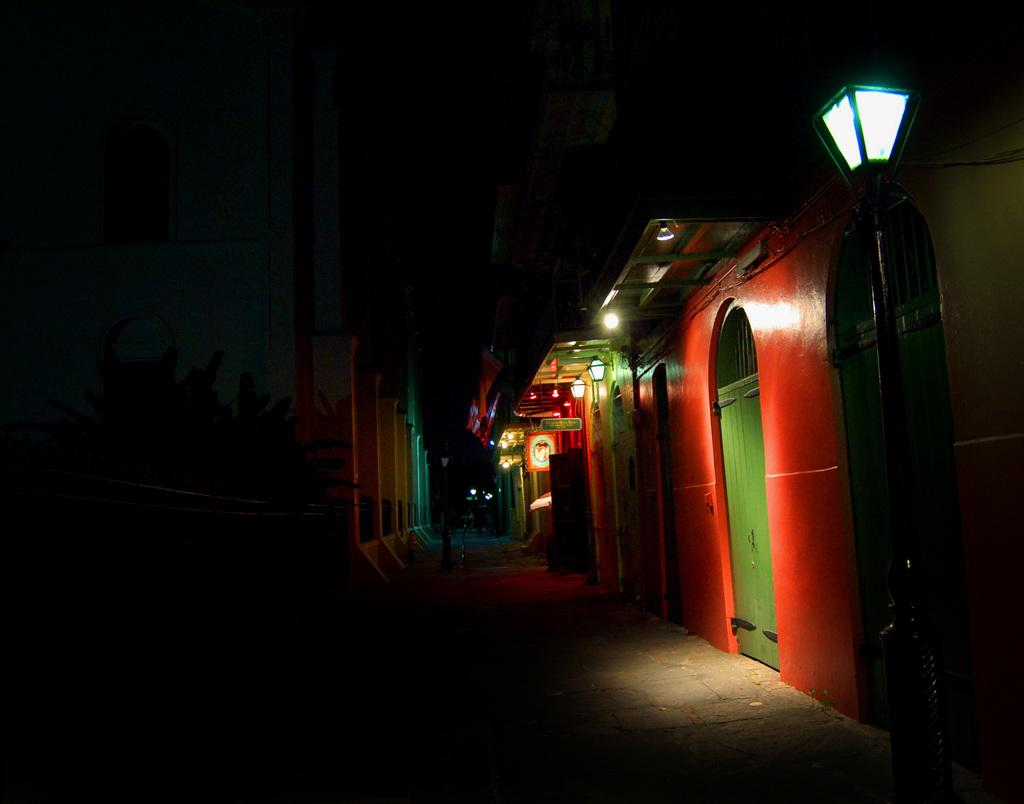What type of structures can be seen in the image? There are buildings in the image. What else can be found in the image besides buildings? There are plants, lights, boards, and poles visible in the image. What is at the bottom of the image? There is a road at the bottom of the image. Where is the store located in the image? There is no store mentioned or visible in the image. Is the image a work of fiction? The image itself is not fiction, but it could be a part of a fictional story or setting. 